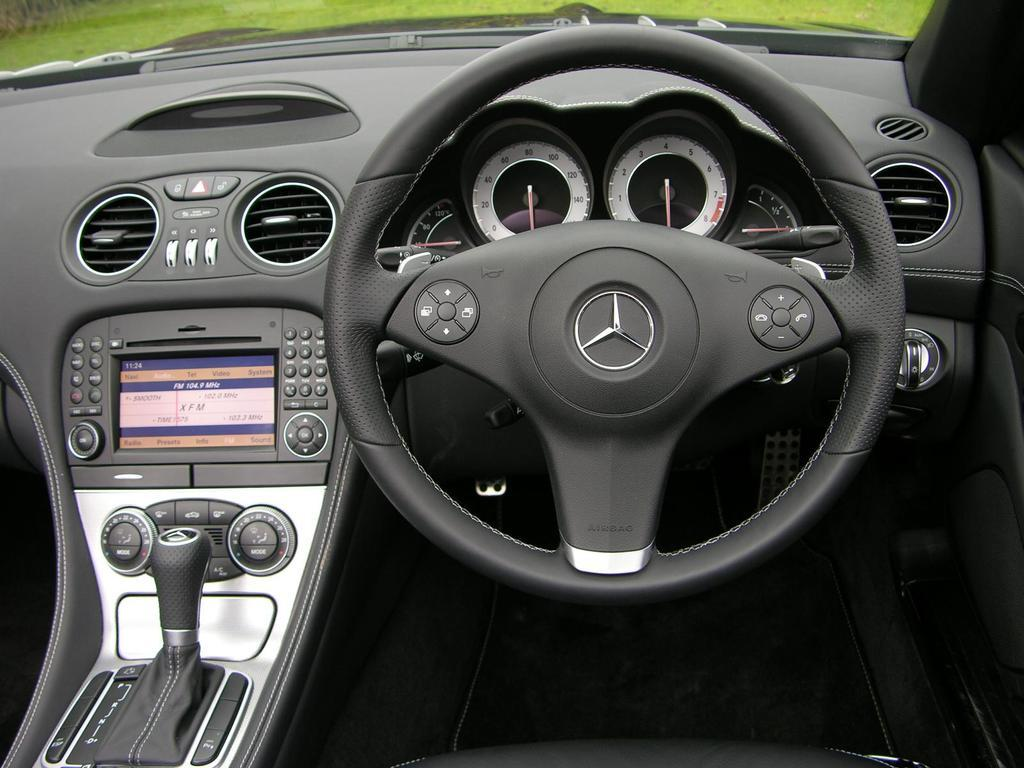Where was the image taken? The image is taken inside a car. What can be seen in the car that is used for driving? There is a steering wheel in the image. What instruments are present in the car to provide information to the driver? There are meters in the image. What is used to start the car? There are keys in the image. What type of landscape can be seen through the glass in the image? The outside view through the glass shows grassland. What historical event is being commemorated by the railway in the image? There is no railway present in the image; it is taken inside a car. 